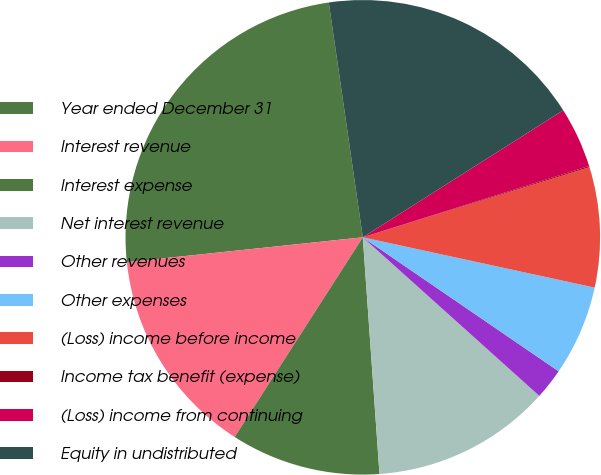Convert chart to OTSL. <chart><loc_0><loc_0><loc_500><loc_500><pie_chart><fcel>Year ended December 31<fcel>Interest revenue<fcel>Interest expense<fcel>Net interest revenue<fcel>Other revenues<fcel>Other expenses<fcel>(Loss) income before income<fcel>Income tax benefit (expense)<fcel>(Loss) income from continuing<fcel>Equity in undistributed<nl><fcel>24.38%<fcel>14.25%<fcel>10.2%<fcel>12.23%<fcel>2.1%<fcel>6.15%<fcel>8.18%<fcel>0.08%<fcel>4.13%<fcel>18.3%<nl></chart> 